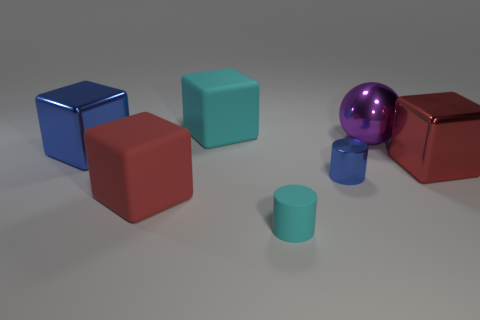Subtract 1 cubes. How many cubes are left? 3 Add 1 large cyan things. How many objects exist? 8 Subtract all blocks. How many objects are left? 3 Add 4 large purple balls. How many large purple balls are left? 5 Add 5 big matte blocks. How many big matte blocks exist? 7 Subtract 0 yellow cylinders. How many objects are left? 7 Subtract all big green shiny things. Subtract all large balls. How many objects are left? 6 